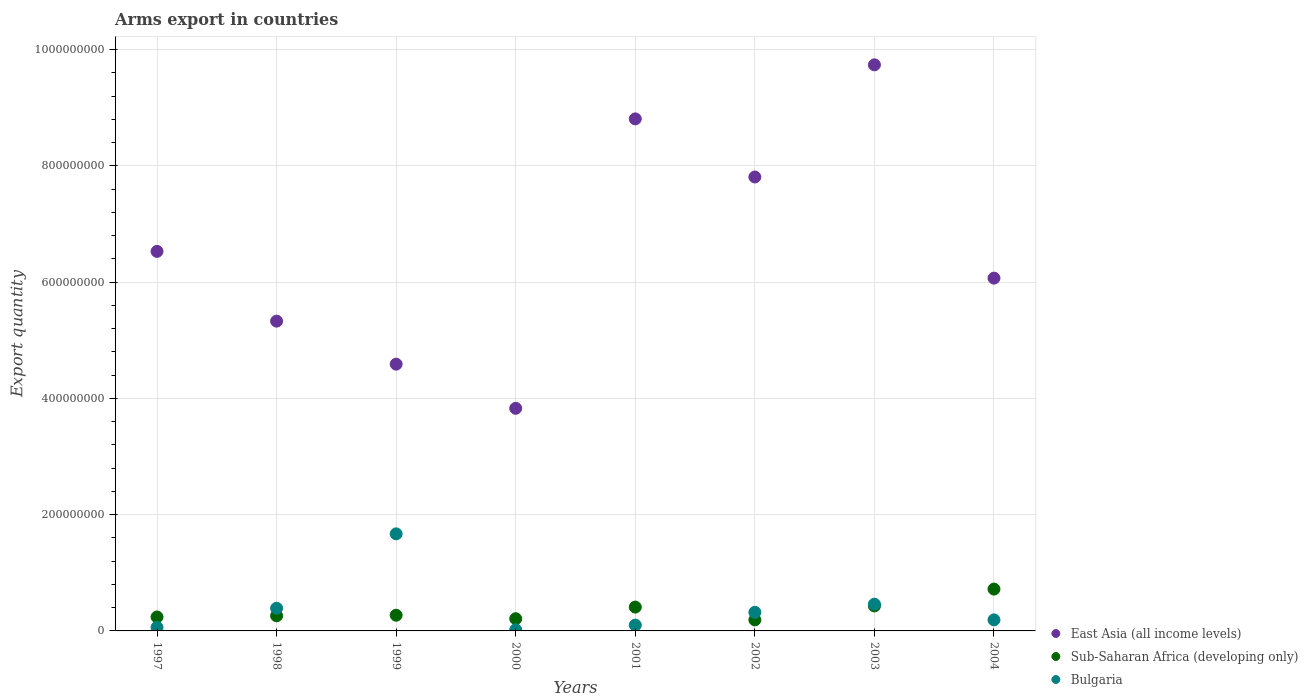How many different coloured dotlines are there?
Give a very brief answer. 3. What is the total arms export in East Asia (all income levels) in 2001?
Offer a terse response. 8.81e+08. Across all years, what is the maximum total arms export in Bulgaria?
Offer a very short reply. 1.67e+08. Across all years, what is the minimum total arms export in East Asia (all income levels)?
Provide a succinct answer. 3.83e+08. In which year was the total arms export in East Asia (all income levels) maximum?
Ensure brevity in your answer.  2003. What is the total total arms export in East Asia (all income levels) in the graph?
Provide a short and direct response. 5.27e+09. What is the difference between the total arms export in Bulgaria in 2001 and that in 2004?
Provide a short and direct response. -9.00e+06. What is the difference between the total arms export in Bulgaria in 1997 and the total arms export in East Asia (all income levels) in 2001?
Provide a short and direct response. -8.75e+08. What is the average total arms export in East Asia (all income levels) per year?
Make the answer very short. 6.59e+08. In the year 2004, what is the difference between the total arms export in East Asia (all income levels) and total arms export in Bulgaria?
Offer a terse response. 5.88e+08. In how many years, is the total arms export in Bulgaria greater than 960000000?
Make the answer very short. 0. What is the ratio of the total arms export in Bulgaria in 1998 to that in 1999?
Keep it short and to the point. 0.23. Is the total arms export in East Asia (all income levels) in 2001 less than that in 2003?
Make the answer very short. Yes. Is the difference between the total arms export in East Asia (all income levels) in 1998 and 2004 greater than the difference between the total arms export in Bulgaria in 1998 and 2004?
Provide a succinct answer. No. What is the difference between the highest and the second highest total arms export in East Asia (all income levels)?
Your response must be concise. 9.30e+07. What is the difference between the highest and the lowest total arms export in Bulgaria?
Offer a very short reply. 1.65e+08. How many dotlines are there?
Provide a short and direct response. 3. What is the difference between two consecutive major ticks on the Y-axis?
Provide a short and direct response. 2.00e+08. Are the values on the major ticks of Y-axis written in scientific E-notation?
Keep it short and to the point. No. Does the graph contain any zero values?
Ensure brevity in your answer.  No. Where does the legend appear in the graph?
Your answer should be compact. Bottom right. What is the title of the graph?
Your answer should be very brief. Arms export in countries. What is the label or title of the Y-axis?
Provide a short and direct response. Export quantity. What is the Export quantity of East Asia (all income levels) in 1997?
Your answer should be compact. 6.53e+08. What is the Export quantity of Sub-Saharan Africa (developing only) in 1997?
Offer a very short reply. 2.40e+07. What is the Export quantity in East Asia (all income levels) in 1998?
Your answer should be compact. 5.33e+08. What is the Export quantity in Sub-Saharan Africa (developing only) in 1998?
Keep it short and to the point. 2.60e+07. What is the Export quantity in Bulgaria in 1998?
Give a very brief answer. 3.90e+07. What is the Export quantity of East Asia (all income levels) in 1999?
Keep it short and to the point. 4.59e+08. What is the Export quantity in Sub-Saharan Africa (developing only) in 1999?
Offer a terse response. 2.70e+07. What is the Export quantity in Bulgaria in 1999?
Keep it short and to the point. 1.67e+08. What is the Export quantity of East Asia (all income levels) in 2000?
Keep it short and to the point. 3.83e+08. What is the Export quantity of Sub-Saharan Africa (developing only) in 2000?
Provide a succinct answer. 2.10e+07. What is the Export quantity in East Asia (all income levels) in 2001?
Offer a terse response. 8.81e+08. What is the Export quantity in Sub-Saharan Africa (developing only) in 2001?
Your answer should be compact. 4.10e+07. What is the Export quantity in Bulgaria in 2001?
Keep it short and to the point. 1.00e+07. What is the Export quantity in East Asia (all income levels) in 2002?
Give a very brief answer. 7.81e+08. What is the Export quantity in Sub-Saharan Africa (developing only) in 2002?
Ensure brevity in your answer.  1.90e+07. What is the Export quantity of Bulgaria in 2002?
Offer a terse response. 3.20e+07. What is the Export quantity of East Asia (all income levels) in 2003?
Offer a terse response. 9.74e+08. What is the Export quantity of Sub-Saharan Africa (developing only) in 2003?
Your answer should be very brief. 4.30e+07. What is the Export quantity of Bulgaria in 2003?
Make the answer very short. 4.60e+07. What is the Export quantity of East Asia (all income levels) in 2004?
Make the answer very short. 6.07e+08. What is the Export quantity of Sub-Saharan Africa (developing only) in 2004?
Give a very brief answer. 7.20e+07. What is the Export quantity of Bulgaria in 2004?
Offer a terse response. 1.90e+07. Across all years, what is the maximum Export quantity in East Asia (all income levels)?
Give a very brief answer. 9.74e+08. Across all years, what is the maximum Export quantity of Sub-Saharan Africa (developing only)?
Offer a terse response. 7.20e+07. Across all years, what is the maximum Export quantity in Bulgaria?
Provide a succinct answer. 1.67e+08. Across all years, what is the minimum Export quantity in East Asia (all income levels)?
Make the answer very short. 3.83e+08. Across all years, what is the minimum Export quantity in Sub-Saharan Africa (developing only)?
Offer a very short reply. 1.90e+07. What is the total Export quantity of East Asia (all income levels) in the graph?
Keep it short and to the point. 5.27e+09. What is the total Export quantity of Sub-Saharan Africa (developing only) in the graph?
Offer a very short reply. 2.73e+08. What is the total Export quantity of Bulgaria in the graph?
Offer a terse response. 3.21e+08. What is the difference between the Export quantity in East Asia (all income levels) in 1997 and that in 1998?
Your answer should be very brief. 1.20e+08. What is the difference between the Export quantity of Sub-Saharan Africa (developing only) in 1997 and that in 1998?
Offer a terse response. -2.00e+06. What is the difference between the Export quantity of Bulgaria in 1997 and that in 1998?
Make the answer very short. -3.30e+07. What is the difference between the Export quantity of East Asia (all income levels) in 1997 and that in 1999?
Keep it short and to the point. 1.94e+08. What is the difference between the Export quantity of Bulgaria in 1997 and that in 1999?
Offer a very short reply. -1.61e+08. What is the difference between the Export quantity of East Asia (all income levels) in 1997 and that in 2000?
Your response must be concise. 2.70e+08. What is the difference between the Export quantity of Sub-Saharan Africa (developing only) in 1997 and that in 2000?
Offer a very short reply. 3.00e+06. What is the difference between the Export quantity of Bulgaria in 1997 and that in 2000?
Provide a short and direct response. 4.00e+06. What is the difference between the Export quantity of East Asia (all income levels) in 1997 and that in 2001?
Your answer should be compact. -2.28e+08. What is the difference between the Export quantity in Sub-Saharan Africa (developing only) in 1997 and that in 2001?
Keep it short and to the point. -1.70e+07. What is the difference between the Export quantity of East Asia (all income levels) in 1997 and that in 2002?
Your answer should be very brief. -1.28e+08. What is the difference between the Export quantity in Bulgaria in 1997 and that in 2002?
Offer a terse response. -2.60e+07. What is the difference between the Export quantity in East Asia (all income levels) in 1997 and that in 2003?
Ensure brevity in your answer.  -3.21e+08. What is the difference between the Export quantity of Sub-Saharan Africa (developing only) in 1997 and that in 2003?
Your answer should be compact. -1.90e+07. What is the difference between the Export quantity in Bulgaria in 1997 and that in 2003?
Your answer should be very brief. -4.00e+07. What is the difference between the Export quantity of East Asia (all income levels) in 1997 and that in 2004?
Your response must be concise. 4.60e+07. What is the difference between the Export quantity of Sub-Saharan Africa (developing only) in 1997 and that in 2004?
Your answer should be compact. -4.80e+07. What is the difference between the Export quantity of Bulgaria in 1997 and that in 2004?
Give a very brief answer. -1.30e+07. What is the difference between the Export quantity of East Asia (all income levels) in 1998 and that in 1999?
Your response must be concise. 7.40e+07. What is the difference between the Export quantity in Sub-Saharan Africa (developing only) in 1998 and that in 1999?
Your response must be concise. -1.00e+06. What is the difference between the Export quantity in Bulgaria in 1998 and that in 1999?
Make the answer very short. -1.28e+08. What is the difference between the Export quantity in East Asia (all income levels) in 1998 and that in 2000?
Keep it short and to the point. 1.50e+08. What is the difference between the Export quantity in Sub-Saharan Africa (developing only) in 1998 and that in 2000?
Offer a terse response. 5.00e+06. What is the difference between the Export quantity of Bulgaria in 1998 and that in 2000?
Provide a short and direct response. 3.70e+07. What is the difference between the Export quantity in East Asia (all income levels) in 1998 and that in 2001?
Ensure brevity in your answer.  -3.48e+08. What is the difference between the Export quantity of Sub-Saharan Africa (developing only) in 1998 and that in 2001?
Your answer should be compact. -1.50e+07. What is the difference between the Export quantity of Bulgaria in 1998 and that in 2001?
Ensure brevity in your answer.  2.90e+07. What is the difference between the Export quantity in East Asia (all income levels) in 1998 and that in 2002?
Keep it short and to the point. -2.48e+08. What is the difference between the Export quantity of Sub-Saharan Africa (developing only) in 1998 and that in 2002?
Provide a short and direct response. 7.00e+06. What is the difference between the Export quantity of Bulgaria in 1998 and that in 2002?
Ensure brevity in your answer.  7.00e+06. What is the difference between the Export quantity of East Asia (all income levels) in 1998 and that in 2003?
Provide a short and direct response. -4.41e+08. What is the difference between the Export quantity in Sub-Saharan Africa (developing only) in 1998 and that in 2003?
Offer a terse response. -1.70e+07. What is the difference between the Export quantity of Bulgaria in 1998 and that in 2003?
Provide a short and direct response. -7.00e+06. What is the difference between the Export quantity in East Asia (all income levels) in 1998 and that in 2004?
Offer a terse response. -7.40e+07. What is the difference between the Export quantity in Sub-Saharan Africa (developing only) in 1998 and that in 2004?
Your response must be concise. -4.60e+07. What is the difference between the Export quantity of East Asia (all income levels) in 1999 and that in 2000?
Provide a short and direct response. 7.60e+07. What is the difference between the Export quantity in Bulgaria in 1999 and that in 2000?
Give a very brief answer. 1.65e+08. What is the difference between the Export quantity of East Asia (all income levels) in 1999 and that in 2001?
Your answer should be compact. -4.22e+08. What is the difference between the Export quantity of Sub-Saharan Africa (developing only) in 1999 and that in 2001?
Ensure brevity in your answer.  -1.40e+07. What is the difference between the Export quantity in Bulgaria in 1999 and that in 2001?
Give a very brief answer. 1.57e+08. What is the difference between the Export quantity of East Asia (all income levels) in 1999 and that in 2002?
Keep it short and to the point. -3.22e+08. What is the difference between the Export quantity in Sub-Saharan Africa (developing only) in 1999 and that in 2002?
Ensure brevity in your answer.  8.00e+06. What is the difference between the Export quantity of Bulgaria in 1999 and that in 2002?
Provide a succinct answer. 1.35e+08. What is the difference between the Export quantity of East Asia (all income levels) in 1999 and that in 2003?
Give a very brief answer. -5.15e+08. What is the difference between the Export quantity in Sub-Saharan Africa (developing only) in 1999 and that in 2003?
Provide a succinct answer. -1.60e+07. What is the difference between the Export quantity of Bulgaria in 1999 and that in 2003?
Your response must be concise. 1.21e+08. What is the difference between the Export quantity of East Asia (all income levels) in 1999 and that in 2004?
Keep it short and to the point. -1.48e+08. What is the difference between the Export quantity of Sub-Saharan Africa (developing only) in 1999 and that in 2004?
Your answer should be very brief. -4.50e+07. What is the difference between the Export quantity of Bulgaria in 1999 and that in 2004?
Your answer should be compact. 1.48e+08. What is the difference between the Export quantity in East Asia (all income levels) in 2000 and that in 2001?
Your answer should be compact. -4.98e+08. What is the difference between the Export quantity of Sub-Saharan Africa (developing only) in 2000 and that in 2001?
Offer a terse response. -2.00e+07. What is the difference between the Export quantity of Bulgaria in 2000 and that in 2001?
Keep it short and to the point. -8.00e+06. What is the difference between the Export quantity in East Asia (all income levels) in 2000 and that in 2002?
Keep it short and to the point. -3.98e+08. What is the difference between the Export quantity in Bulgaria in 2000 and that in 2002?
Keep it short and to the point. -3.00e+07. What is the difference between the Export quantity in East Asia (all income levels) in 2000 and that in 2003?
Provide a succinct answer. -5.91e+08. What is the difference between the Export quantity of Sub-Saharan Africa (developing only) in 2000 and that in 2003?
Offer a very short reply. -2.20e+07. What is the difference between the Export quantity in Bulgaria in 2000 and that in 2003?
Keep it short and to the point. -4.40e+07. What is the difference between the Export quantity of East Asia (all income levels) in 2000 and that in 2004?
Your answer should be very brief. -2.24e+08. What is the difference between the Export quantity in Sub-Saharan Africa (developing only) in 2000 and that in 2004?
Keep it short and to the point. -5.10e+07. What is the difference between the Export quantity of Bulgaria in 2000 and that in 2004?
Provide a short and direct response. -1.70e+07. What is the difference between the Export quantity of Sub-Saharan Africa (developing only) in 2001 and that in 2002?
Offer a terse response. 2.20e+07. What is the difference between the Export quantity of Bulgaria in 2001 and that in 2002?
Provide a succinct answer. -2.20e+07. What is the difference between the Export quantity in East Asia (all income levels) in 2001 and that in 2003?
Offer a terse response. -9.30e+07. What is the difference between the Export quantity of Bulgaria in 2001 and that in 2003?
Ensure brevity in your answer.  -3.60e+07. What is the difference between the Export quantity in East Asia (all income levels) in 2001 and that in 2004?
Give a very brief answer. 2.74e+08. What is the difference between the Export quantity of Sub-Saharan Africa (developing only) in 2001 and that in 2004?
Provide a short and direct response. -3.10e+07. What is the difference between the Export quantity of Bulgaria in 2001 and that in 2004?
Give a very brief answer. -9.00e+06. What is the difference between the Export quantity of East Asia (all income levels) in 2002 and that in 2003?
Give a very brief answer. -1.93e+08. What is the difference between the Export quantity in Sub-Saharan Africa (developing only) in 2002 and that in 2003?
Give a very brief answer. -2.40e+07. What is the difference between the Export quantity in Bulgaria in 2002 and that in 2003?
Provide a short and direct response. -1.40e+07. What is the difference between the Export quantity in East Asia (all income levels) in 2002 and that in 2004?
Provide a short and direct response. 1.74e+08. What is the difference between the Export quantity of Sub-Saharan Africa (developing only) in 2002 and that in 2004?
Keep it short and to the point. -5.30e+07. What is the difference between the Export quantity in Bulgaria in 2002 and that in 2004?
Your answer should be compact. 1.30e+07. What is the difference between the Export quantity of East Asia (all income levels) in 2003 and that in 2004?
Your answer should be very brief. 3.67e+08. What is the difference between the Export quantity in Sub-Saharan Africa (developing only) in 2003 and that in 2004?
Offer a terse response. -2.90e+07. What is the difference between the Export quantity in Bulgaria in 2003 and that in 2004?
Keep it short and to the point. 2.70e+07. What is the difference between the Export quantity in East Asia (all income levels) in 1997 and the Export quantity in Sub-Saharan Africa (developing only) in 1998?
Keep it short and to the point. 6.27e+08. What is the difference between the Export quantity in East Asia (all income levels) in 1997 and the Export quantity in Bulgaria in 1998?
Give a very brief answer. 6.14e+08. What is the difference between the Export quantity of Sub-Saharan Africa (developing only) in 1997 and the Export quantity of Bulgaria in 1998?
Make the answer very short. -1.50e+07. What is the difference between the Export quantity in East Asia (all income levels) in 1997 and the Export quantity in Sub-Saharan Africa (developing only) in 1999?
Provide a short and direct response. 6.26e+08. What is the difference between the Export quantity of East Asia (all income levels) in 1997 and the Export quantity of Bulgaria in 1999?
Your response must be concise. 4.86e+08. What is the difference between the Export quantity of Sub-Saharan Africa (developing only) in 1997 and the Export quantity of Bulgaria in 1999?
Ensure brevity in your answer.  -1.43e+08. What is the difference between the Export quantity in East Asia (all income levels) in 1997 and the Export quantity in Sub-Saharan Africa (developing only) in 2000?
Provide a short and direct response. 6.32e+08. What is the difference between the Export quantity in East Asia (all income levels) in 1997 and the Export quantity in Bulgaria in 2000?
Provide a short and direct response. 6.51e+08. What is the difference between the Export quantity of Sub-Saharan Africa (developing only) in 1997 and the Export quantity of Bulgaria in 2000?
Provide a short and direct response. 2.20e+07. What is the difference between the Export quantity of East Asia (all income levels) in 1997 and the Export quantity of Sub-Saharan Africa (developing only) in 2001?
Provide a succinct answer. 6.12e+08. What is the difference between the Export quantity in East Asia (all income levels) in 1997 and the Export quantity in Bulgaria in 2001?
Ensure brevity in your answer.  6.43e+08. What is the difference between the Export quantity in Sub-Saharan Africa (developing only) in 1997 and the Export quantity in Bulgaria in 2001?
Keep it short and to the point. 1.40e+07. What is the difference between the Export quantity in East Asia (all income levels) in 1997 and the Export quantity in Sub-Saharan Africa (developing only) in 2002?
Offer a very short reply. 6.34e+08. What is the difference between the Export quantity of East Asia (all income levels) in 1997 and the Export quantity of Bulgaria in 2002?
Offer a terse response. 6.21e+08. What is the difference between the Export quantity of Sub-Saharan Africa (developing only) in 1997 and the Export quantity of Bulgaria in 2002?
Your answer should be compact. -8.00e+06. What is the difference between the Export quantity of East Asia (all income levels) in 1997 and the Export quantity of Sub-Saharan Africa (developing only) in 2003?
Keep it short and to the point. 6.10e+08. What is the difference between the Export quantity in East Asia (all income levels) in 1997 and the Export quantity in Bulgaria in 2003?
Keep it short and to the point. 6.07e+08. What is the difference between the Export quantity of Sub-Saharan Africa (developing only) in 1997 and the Export quantity of Bulgaria in 2003?
Keep it short and to the point. -2.20e+07. What is the difference between the Export quantity of East Asia (all income levels) in 1997 and the Export quantity of Sub-Saharan Africa (developing only) in 2004?
Provide a short and direct response. 5.81e+08. What is the difference between the Export quantity in East Asia (all income levels) in 1997 and the Export quantity in Bulgaria in 2004?
Your answer should be compact. 6.34e+08. What is the difference between the Export quantity in Sub-Saharan Africa (developing only) in 1997 and the Export quantity in Bulgaria in 2004?
Give a very brief answer. 5.00e+06. What is the difference between the Export quantity of East Asia (all income levels) in 1998 and the Export quantity of Sub-Saharan Africa (developing only) in 1999?
Offer a terse response. 5.06e+08. What is the difference between the Export quantity in East Asia (all income levels) in 1998 and the Export quantity in Bulgaria in 1999?
Provide a succinct answer. 3.66e+08. What is the difference between the Export quantity in Sub-Saharan Africa (developing only) in 1998 and the Export quantity in Bulgaria in 1999?
Your answer should be very brief. -1.41e+08. What is the difference between the Export quantity of East Asia (all income levels) in 1998 and the Export quantity of Sub-Saharan Africa (developing only) in 2000?
Ensure brevity in your answer.  5.12e+08. What is the difference between the Export quantity in East Asia (all income levels) in 1998 and the Export quantity in Bulgaria in 2000?
Offer a terse response. 5.31e+08. What is the difference between the Export quantity of Sub-Saharan Africa (developing only) in 1998 and the Export quantity of Bulgaria in 2000?
Your response must be concise. 2.40e+07. What is the difference between the Export quantity in East Asia (all income levels) in 1998 and the Export quantity in Sub-Saharan Africa (developing only) in 2001?
Your answer should be very brief. 4.92e+08. What is the difference between the Export quantity in East Asia (all income levels) in 1998 and the Export quantity in Bulgaria in 2001?
Keep it short and to the point. 5.23e+08. What is the difference between the Export quantity of Sub-Saharan Africa (developing only) in 1998 and the Export quantity of Bulgaria in 2001?
Your response must be concise. 1.60e+07. What is the difference between the Export quantity in East Asia (all income levels) in 1998 and the Export quantity in Sub-Saharan Africa (developing only) in 2002?
Offer a very short reply. 5.14e+08. What is the difference between the Export quantity in East Asia (all income levels) in 1998 and the Export quantity in Bulgaria in 2002?
Make the answer very short. 5.01e+08. What is the difference between the Export quantity of Sub-Saharan Africa (developing only) in 1998 and the Export quantity of Bulgaria in 2002?
Your answer should be compact. -6.00e+06. What is the difference between the Export quantity in East Asia (all income levels) in 1998 and the Export quantity in Sub-Saharan Africa (developing only) in 2003?
Make the answer very short. 4.90e+08. What is the difference between the Export quantity of East Asia (all income levels) in 1998 and the Export quantity of Bulgaria in 2003?
Give a very brief answer. 4.87e+08. What is the difference between the Export quantity of Sub-Saharan Africa (developing only) in 1998 and the Export quantity of Bulgaria in 2003?
Provide a short and direct response. -2.00e+07. What is the difference between the Export quantity of East Asia (all income levels) in 1998 and the Export quantity of Sub-Saharan Africa (developing only) in 2004?
Provide a short and direct response. 4.61e+08. What is the difference between the Export quantity of East Asia (all income levels) in 1998 and the Export quantity of Bulgaria in 2004?
Make the answer very short. 5.14e+08. What is the difference between the Export quantity in East Asia (all income levels) in 1999 and the Export quantity in Sub-Saharan Africa (developing only) in 2000?
Give a very brief answer. 4.38e+08. What is the difference between the Export quantity of East Asia (all income levels) in 1999 and the Export quantity of Bulgaria in 2000?
Give a very brief answer. 4.57e+08. What is the difference between the Export quantity in Sub-Saharan Africa (developing only) in 1999 and the Export quantity in Bulgaria in 2000?
Offer a very short reply. 2.50e+07. What is the difference between the Export quantity in East Asia (all income levels) in 1999 and the Export quantity in Sub-Saharan Africa (developing only) in 2001?
Provide a succinct answer. 4.18e+08. What is the difference between the Export quantity of East Asia (all income levels) in 1999 and the Export quantity of Bulgaria in 2001?
Offer a very short reply. 4.49e+08. What is the difference between the Export quantity of Sub-Saharan Africa (developing only) in 1999 and the Export quantity of Bulgaria in 2001?
Your answer should be compact. 1.70e+07. What is the difference between the Export quantity of East Asia (all income levels) in 1999 and the Export quantity of Sub-Saharan Africa (developing only) in 2002?
Offer a terse response. 4.40e+08. What is the difference between the Export quantity in East Asia (all income levels) in 1999 and the Export quantity in Bulgaria in 2002?
Keep it short and to the point. 4.27e+08. What is the difference between the Export quantity in Sub-Saharan Africa (developing only) in 1999 and the Export quantity in Bulgaria in 2002?
Offer a terse response. -5.00e+06. What is the difference between the Export quantity in East Asia (all income levels) in 1999 and the Export quantity in Sub-Saharan Africa (developing only) in 2003?
Provide a succinct answer. 4.16e+08. What is the difference between the Export quantity of East Asia (all income levels) in 1999 and the Export quantity of Bulgaria in 2003?
Keep it short and to the point. 4.13e+08. What is the difference between the Export quantity of Sub-Saharan Africa (developing only) in 1999 and the Export quantity of Bulgaria in 2003?
Ensure brevity in your answer.  -1.90e+07. What is the difference between the Export quantity in East Asia (all income levels) in 1999 and the Export quantity in Sub-Saharan Africa (developing only) in 2004?
Your response must be concise. 3.87e+08. What is the difference between the Export quantity of East Asia (all income levels) in 1999 and the Export quantity of Bulgaria in 2004?
Provide a short and direct response. 4.40e+08. What is the difference between the Export quantity in Sub-Saharan Africa (developing only) in 1999 and the Export quantity in Bulgaria in 2004?
Make the answer very short. 8.00e+06. What is the difference between the Export quantity in East Asia (all income levels) in 2000 and the Export quantity in Sub-Saharan Africa (developing only) in 2001?
Your answer should be compact. 3.42e+08. What is the difference between the Export quantity of East Asia (all income levels) in 2000 and the Export quantity of Bulgaria in 2001?
Keep it short and to the point. 3.73e+08. What is the difference between the Export quantity in Sub-Saharan Africa (developing only) in 2000 and the Export quantity in Bulgaria in 2001?
Offer a terse response. 1.10e+07. What is the difference between the Export quantity of East Asia (all income levels) in 2000 and the Export quantity of Sub-Saharan Africa (developing only) in 2002?
Ensure brevity in your answer.  3.64e+08. What is the difference between the Export quantity in East Asia (all income levels) in 2000 and the Export quantity in Bulgaria in 2002?
Offer a terse response. 3.51e+08. What is the difference between the Export quantity in Sub-Saharan Africa (developing only) in 2000 and the Export quantity in Bulgaria in 2002?
Make the answer very short. -1.10e+07. What is the difference between the Export quantity of East Asia (all income levels) in 2000 and the Export quantity of Sub-Saharan Africa (developing only) in 2003?
Your answer should be compact. 3.40e+08. What is the difference between the Export quantity of East Asia (all income levels) in 2000 and the Export quantity of Bulgaria in 2003?
Your response must be concise. 3.37e+08. What is the difference between the Export quantity of Sub-Saharan Africa (developing only) in 2000 and the Export quantity of Bulgaria in 2003?
Ensure brevity in your answer.  -2.50e+07. What is the difference between the Export quantity in East Asia (all income levels) in 2000 and the Export quantity in Sub-Saharan Africa (developing only) in 2004?
Your answer should be very brief. 3.11e+08. What is the difference between the Export quantity of East Asia (all income levels) in 2000 and the Export quantity of Bulgaria in 2004?
Ensure brevity in your answer.  3.64e+08. What is the difference between the Export quantity of East Asia (all income levels) in 2001 and the Export quantity of Sub-Saharan Africa (developing only) in 2002?
Your response must be concise. 8.62e+08. What is the difference between the Export quantity of East Asia (all income levels) in 2001 and the Export quantity of Bulgaria in 2002?
Ensure brevity in your answer.  8.49e+08. What is the difference between the Export quantity of Sub-Saharan Africa (developing only) in 2001 and the Export quantity of Bulgaria in 2002?
Provide a short and direct response. 9.00e+06. What is the difference between the Export quantity in East Asia (all income levels) in 2001 and the Export quantity in Sub-Saharan Africa (developing only) in 2003?
Offer a terse response. 8.38e+08. What is the difference between the Export quantity of East Asia (all income levels) in 2001 and the Export quantity of Bulgaria in 2003?
Your answer should be very brief. 8.35e+08. What is the difference between the Export quantity in Sub-Saharan Africa (developing only) in 2001 and the Export quantity in Bulgaria in 2003?
Ensure brevity in your answer.  -5.00e+06. What is the difference between the Export quantity in East Asia (all income levels) in 2001 and the Export quantity in Sub-Saharan Africa (developing only) in 2004?
Keep it short and to the point. 8.09e+08. What is the difference between the Export quantity in East Asia (all income levels) in 2001 and the Export quantity in Bulgaria in 2004?
Your answer should be very brief. 8.62e+08. What is the difference between the Export quantity of Sub-Saharan Africa (developing only) in 2001 and the Export quantity of Bulgaria in 2004?
Your answer should be very brief. 2.20e+07. What is the difference between the Export quantity in East Asia (all income levels) in 2002 and the Export quantity in Sub-Saharan Africa (developing only) in 2003?
Keep it short and to the point. 7.38e+08. What is the difference between the Export quantity in East Asia (all income levels) in 2002 and the Export quantity in Bulgaria in 2003?
Offer a very short reply. 7.35e+08. What is the difference between the Export quantity of Sub-Saharan Africa (developing only) in 2002 and the Export quantity of Bulgaria in 2003?
Your answer should be very brief. -2.70e+07. What is the difference between the Export quantity of East Asia (all income levels) in 2002 and the Export quantity of Sub-Saharan Africa (developing only) in 2004?
Offer a terse response. 7.09e+08. What is the difference between the Export quantity of East Asia (all income levels) in 2002 and the Export quantity of Bulgaria in 2004?
Give a very brief answer. 7.62e+08. What is the difference between the Export quantity of East Asia (all income levels) in 2003 and the Export quantity of Sub-Saharan Africa (developing only) in 2004?
Provide a succinct answer. 9.02e+08. What is the difference between the Export quantity of East Asia (all income levels) in 2003 and the Export quantity of Bulgaria in 2004?
Offer a terse response. 9.55e+08. What is the difference between the Export quantity in Sub-Saharan Africa (developing only) in 2003 and the Export quantity in Bulgaria in 2004?
Ensure brevity in your answer.  2.40e+07. What is the average Export quantity of East Asia (all income levels) per year?
Ensure brevity in your answer.  6.59e+08. What is the average Export quantity of Sub-Saharan Africa (developing only) per year?
Keep it short and to the point. 3.41e+07. What is the average Export quantity in Bulgaria per year?
Keep it short and to the point. 4.01e+07. In the year 1997, what is the difference between the Export quantity in East Asia (all income levels) and Export quantity in Sub-Saharan Africa (developing only)?
Offer a terse response. 6.29e+08. In the year 1997, what is the difference between the Export quantity of East Asia (all income levels) and Export quantity of Bulgaria?
Give a very brief answer. 6.47e+08. In the year 1997, what is the difference between the Export quantity in Sub-Saharan Africa (developing only) and Export quantity in Bulgaria?
Offer a very short reply. 1.80e+07. In the year 1998, what is the difference between the Export quantity of East Asia (all income levels) and Export quantity of Sub-Saharan Africa (developing only)?
Ensure brevity in your answer.  5.07e+08. In the year 1998, what is the difference between the Export quantity in East Asia (all income levels) and Export quantity in Bulgaria?
Provide a short and direct response. 4.94e+08. In the year 1998, what is the difference between the Export quantity in Sub-Saharan Africa (developing only) and Export quantity in Bulgaria?
Your answer should be compact. -1.30e+07. In the year 1999, what is the difference between the Export quantity in East Asia (all income levels) and Export quantity in Sub-Saharan Africa (developing only)?
Offer a very short reply. 4.32e+08. In the year 1999, what is the difference between the Export quantity of East Asia (all income levels) and Export quantity of Bulgaria?
Ensure brevity in your answer.  2.92e+08. In the year 1999, what is the difference between the Export quantity of Sub-Saharan Africa (developing only) and Export quantity of Bulgaria?
Provide a succinct answer. -1.40e+08. In the year 2000, what is the difference between the Export quantity in East Asia (all income levels) and Export quantity in Sub-Saharan Africa (developing only)?
Ensure brevity in your answer.  3.62e+08. In the year 2000, what is the difference between the Export quantity of East Asia (all income levels) and Export quantity of Bulgaria?
Ensure brevity in your answer.  3.81e+08. In the year 2000, what is the difference between the Export quantity in Sub-Saharan Africa (developing only) and Export quantity in Bulgaria?
Provide a short and direct response. 1.90e+07. In the year 2001, what is the difference between the Export quantity of East Asia (all income levels) and Export quantity of Sub-Saharan Africa (developing only)?
Your answer should be compact. 8.40e+08. In the year 2001, what is the difference between the Export quantity of East Asia (all income levels) and Export quantity of Bulgaria?
Offer a very short reply. 8.71e+08. In the year 2001, what is the difference between the Export quantity in Sub-Saharan Africa (developing only) and Export quantity in Bulgaria?
Ensure brevity in your answer.  3.10e+07. In the year 2002, what is the difference between the Export quantity in East Asia (all income levels) and Export quantity in Sub-Saharan Africa (developing only)?
Give a very brief answer. 7.62e+08. In the year 2002, what is the difference between the Export quantity of East Asia (all income levels) and Export quantity of Bulgaria?
Ensure brevity in your answer.  7.49e+08. In the year 2002, what is the difference between the Export quantity of Sub-Saharan Africa (developing only) and Export quantity of Bulgaria?
Your answer should be compact. -1.30e+07. In the year 2003, what is the difference between the Export quantity of East Asia (all income levels) and Export quantity of Sub-Saharan Africa (developing only)?
Your answer should be compact. 9.31e+08. In the year 2003, what is the difference between the Export quantity of East Asia (all income levels) and Export quantity of Bulgaria?
Make the answer very short. 9.28e+08. In the year 2004, what is the difference between the Export quantity of East Asia (all income levels) and Export quantity of Sub-Saharan Africa (developing only)?
Give a very brief answer. 5.35e+08. In the year 2004, what is the difference between the Export quantity of East Asia (all income levels) and Export quantity of Bulgaria?
Your answer should be compact. 5.88e+08. In the year 2004, what is the difference between the Export quantity of Sub-Saharan Africa (developing only) and Export quantity of Bulgaria?
Ensure brevity in your answer.  5.30e+07. What is the ratio of the Export quantity of East Asia (all income levels) in 1997 to that in 1998?
Offer a very short reply. 1.23. What is the ratio of the Export quantity of Bulgaria in 1997 to that in 1998?
Provide a succinct answer. 0.15. What is the ratio of the Export quantity in East Asia (all income levels) in 1997 to that in 1999?
Offer a terse response. 1.42. What is the ratio of the Export quantity in Sub-Saharan Africa (developing only) in 1997 to that in 1999?
Give a very brief answer. 0.89. What is the ratio of the Export quantity of Bulgaria in 1997 to that in 1999?
Keep it short and to the point. 0.04. What is the ratio of the Export quantity of East Asia (all income levels) in 1997 to that in 2000?
Provide a succinct answer. 1.71. What is the ratio of the Export quantity of Sub-Saharan Africa (developing only) in 1997 to that in 2000?
Your answer should be compact. 1.14. What is the ratio of the Export quantity of East Asia (all income levels) in 1997 to that in 2001?
Keep it short and to the point. 0.74. What is the ratio of the Export quantity in Sub-Saharan Africa (developing only) in 1997 to that in 2001?
Provide a succinct answer. 0.59. What is the ratio of the Export quantity of East Asia (all income levels) in 1997 to that in 2002?
Provide a succinct answer. 0.84. What is the ratio of the Export quantity in Sub-Saharan Africa (developing only) in 1997 to that in 2002?
Provide a short and direct response. 1.26. What is the ratio of the Export quantity in Bulgaria in 1997 to that in 2002?
Give a very brief answer. 0.19. What is the ratio of the Export quantity of East Asia (all income levels) in 1997 to that in 2003?
Offer a terse response. 0.67. What is the ratio of the Export quantity of Sub-Saharan Africa (developing only) in 1997 to that in 2003?
Offer a terse response. 0.56. What is the ratio of the Export quantity of Bulgaria in 1997 to that in 2003?
Your answer should be very brief. 0.13. What is the ratio of the Export quantity in East Asia (all income levels) in 1997 to that in 2004?
Provide a short and direct response. 1.08. What is the ratio of the Export quantity of Bulgaria in 1997 to that in 2004?
Keep it short and to the point. 0.32. What is the ratio of the Export quantity of East Asia (all income levels) in 1998 to that in 1999?
Give a very brief answer. 1.16. What is the ratio of the Export quantity of Bulgaria in 1998 to that in 1999?
Your answer should be compact. 0.23. What is the ratio of the Export quantity in East Asia (all income levels) in 1998 to that in 2000?
Your answer should be very brief. 1.39. What is the ratio of the Export quantity of Sub-Saharan Africa (developing only) in 1998 to that in 2000?
Ensure brevity in your answer.  1.24. What is the ratio of the Export quantity in East Asia (all income levels) in 1998 to that in 2001?
Make the answer very short. 0.6. What is the ratio of the Export quantity of Sub-Saharan Africa (developing only) in 1998 to that in 2001?
Provide a short and direct response. 0.63. What is the ratio of the Export quantity of Bulgaria in 1998 to that in 2001?
Give a very brief answer. 3.9. What is the ratio of the Export quantity of East Asia (all income levels) in 1998 to that in 2002?
Make the answer very short. 0.68. What is the ratio of the Export quantity of Sub-Saharan Africa (developing only) in 1998 to that in 2002?
Your answer should be very brief. 1.37. What is the ratio of the Export quantity of Bulgaria in 1998 to that in 2002?
Provide a succinct answer. 1.22. What is the ratio of the Export quantity of East Asia (all income levels) in 1998 to that in 2003?
Provide a succinct answer. 0.55. What is the ratio of the Export quantity of Sub-Saharan Africa (developing only) in 1998 to that in 2003?
Provide a succinct answer. 0.6. What is the ratio of the Export quantity in Bulgaria in 1998 to that in 2003?
Your response must be concise. 0.85. What is the ratio of the Export quantity in East Asia (all income levels) in 1998 to that in 2004?
Keep it short and to the point. 0.88. What is the ratio of the Export quantity in Sub-Saharan Africa (developing only) in 1998 to that in 2004?
Offer a terse response. 0.36. What is the ratio of the Export quantity of Bulgaria in 1998 to that in 2004?
Make the answer very short. 2.05. What is the ratio of the Export quantity in East Asia (all income levels) in 1999 to that in 2000?
Offer a terse response. 1.2. What is the ratio of the Export quantity of Sub-Saharan Africa (developing only) in 1999 to that in 2000?
Keep it short and to the point. 1.29. What is the ratio of the Export quantity of Bulgaria in 1999 to that in 2000?
Your answer should be very brief. 83.5. What is the ratio of the Export quantity of East Asia (all income levels) in 1999 to that in 2001?
Your answer should be compact. 0.52. What is the ratio of the Export quantity of Sub-Saharan Africa (developing only) in 1999 to that in 2001?
Ensure brevity in your answer.  0.66. What is the ratio of the Export quantity in East Asia (all income levels) in 1999 to that in 2002?
Offer a terse response. 0.59. What is the ratio of the Export quantity in Sub-Saharan Africa (developing only) in 1999 to that in 2002?
Provide a succinct answer. 1.42. What is the ratio of the Export quantity of Bulgaria in 1999 to that in 2002?
Keep it short and to the point. 5.22. What is the ratio of the Export quantity in East Asia (all income levels) in 1999 to that in 2003?
Ensure brevity in your answer.  0.47. What is the ratio of the Export quantity in Sub-Saharan Africa (developing only) in 1999 to that in 2003?
Offer a terse response. 0.63. What is the ratio of the Export quantity in Bulgaria in 1999 to that in 2003?
Make the answer very short. 3.63. What is the ratio of the Export quantity of East Asia (all income levels) in 1999 to that in 2004?
Keep it short and to the point. 0.76. What is the ratio of the Export quantity of Bulgaria in 1999 to that in 2004?
Your answer should be compact. 8.79. What is the ratio of the Export quantity in East Asia (all income levels) in 2000 to that in 2001?
Give a very brief answer. 0.43. What is the ratio of the Export quantity in Sub-Saharan Africa (developing only) in 2000 to that in 2001?
Make the answer very short. 0.51. What is the ratio of the Export quantity of Bulgaria in 2000 to that in 2001?
Make the answer very short. 0.2. What is the ratio of the Export quantity in East Asia (all income levels) in 2000 to that in 2002?
Make the answer very short. 0.49. What is the ratio of the Export quantity in Sub-Saharan Africa (developing only) in 2000 to that in 2002?
Offer a terse response. 1.11. What is the ratio of the Export quantity of Bulgaria in 2000 to that in 2002?
Keep it short and to the point. 0.06. What is the ratio of the Export quantity in East Asia (all income levels) in 2000 to that in 2003?
Ensure brevity in your answer.  0.39. What is the ratio of the Export quantity of Sub-Saharan Africa (developing only) in 2000 to that in 2003?
Ensure brevity in your answer.  0.49. What is the ratio of the Export quantity in Bulgaria in 2000 to that in 2003?
Keep it short and to the point. 0.04. What is the ratio of the Export quantity of East Asia (all income levels) in 2000 to that in 2004?
Keep it short and to the point. 0.63. What is the ratio of the Export quantity of Sub-Saharan Africa (developing only) in 2000 to that in 2004?
Make the answer very short. 0.29. What is the ratio of the Export quantity in Bulgaria in 2000 to that in 2004?
Your answer should be very brief. 0.11. What is the ratio of the Export quantity in East Asia (all income levels) in 2001 to that in 2002?
Ensure brevity in your answer.  1.13. What is the ratio of the Export quantity in Sub-Saharan Africa (developing only) in 2001 to that in 2002?
Your response must be concise. 2.16. What is the ratio of the Export quantity in Bulgaria in 2001 to that in 2002?
Provide a short and direct response. 0.31. What is the ratio of the Export quantity in East Asia (all income levels) in 2001 to that in 2003?
Provide a succinct answer. 0.9. What is the ratio of the Export quantity of Sub-Saharan Africa (developing only) in 2001 to that in 2003?
Your response must be concise. 0.95. What is the ratio of the Export quantity of Bulgaria in 2001 to that in 2003?
Keep it short and to the point. 0.22. What is the ratio of the Export quantity in East Asia (all income levels) in 2001 to that in 2004?
Make the answer very short. 1.45. What is the ratio of the Export quantity in Sub-Saharan Africa (developing only) in 2001 to that in 2004?
Your answer should be very brief. 0.57. What is the ratio of the Export quantity in Bulgaria in 2001 to that in 2004?
Provide a short and direct response. 0.53. What is the ratio of the Export quantity of East Asia (all income levels) in 2002 to that in 2003?
Your answer should be compact. 0.8. What is the ratio of the Export quantity of Sub-Saharan Africa (developing only) in 2002 to that in 2003?
Ensure brevity in your answer.  0.44. What is the ratio of the Export quantity of Bulgaria in 2002 to that in 2003?
Your response must be concise. 0.7. What is the ratio of the Export quantity in East Asia (all income levels) in 2002 to that in 2004?
Provide a succinct answer. 1.29. What is the ratio of the Export quantity in Sub-Saharan Africa (developing only) in 2002 to that in 2004?
Offer a terse response. 0.26. What is the ratio of the Export quantity of Bulgaria in 2002 to that in 2004?
Keep it short and to the point. 1.68. What is the ratio of the Export quantity in East Asia (all income levels) in 2003 to that in 2004?
Ensure brevity in your answer.  1.6. What is the ratio of the Export quantity of Sub-Saharan Africa (developing only) in 2003 to that in 2004?
Give a very brief answer. 0.6. What is the ratio of the Export quantity in Bulgaria in 2003 to that in 2004?
Your response must be concise. 2.42. What is the difference between the highest and the second highest Export quantity of East Asia (all income levels)?
Your answer should be very brief. 9.30e+07. What is the difference between the highest and the second highest Export quantity of Sub-Saharan Africa (developing only)?
Keep it short and to the point. 2.90e+07. What is the difference between the highest and the second highest Export quantity of Bulgaria?
Your answer should be very brief. 1.21e+08. What is the difference between the highest and the lowest Export quantity in East Asia (all income levels)?
Give a very brief answer. 5.91e+08. What is the difference between the highest and the lowest Export quantity in Sub-Saharan Africa (developing only)?
Keep it short and to the point. 5.30e+07. What is the difference between the highest and the lowest Export quantity of Bulgaria?
Give a very brief answer. 1.65e+08. 